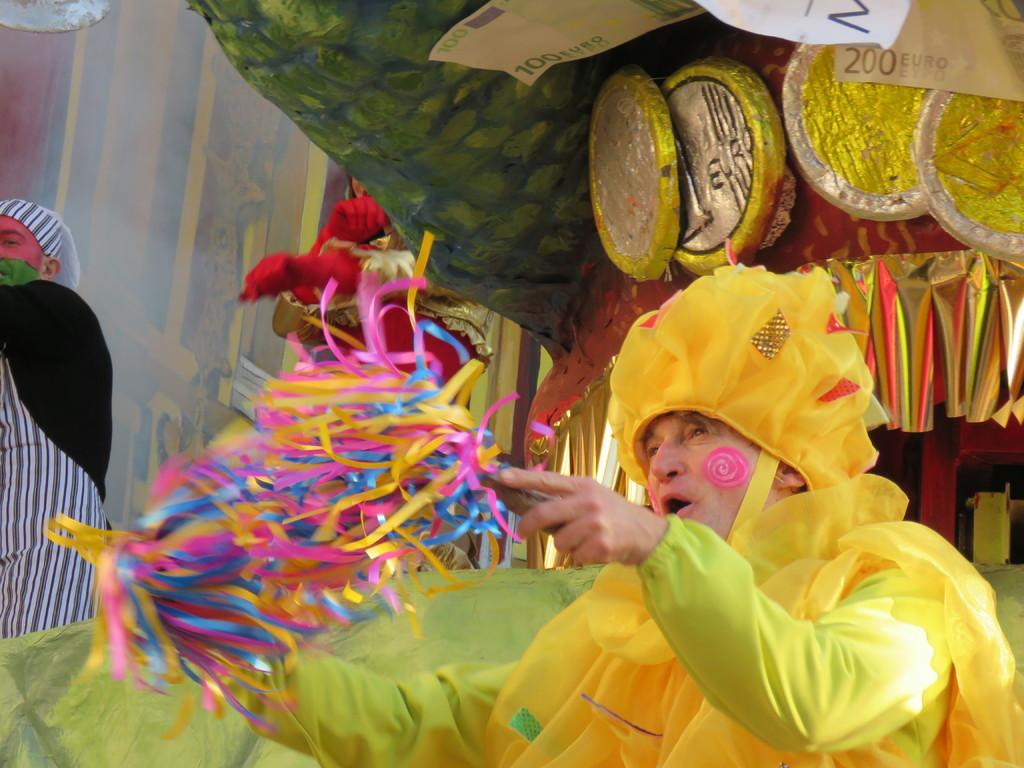What is the person in the foreground holding in their hands? The fact does not specify what the person is holding, so we cannot determine that from the information provided. Can you describe the person in the background? The fact only mentions that there is another person in the background, but it does not provide any details about their appearance or actions. What other unspecified things can be seen in the background? The fact only mentions that there are other unspecified things visible in the background, but it does not describe what they are. What type of ice can be seen melting on the sheet in the image? There is no sheet or ice present in the image, so this question cannot be answered. 